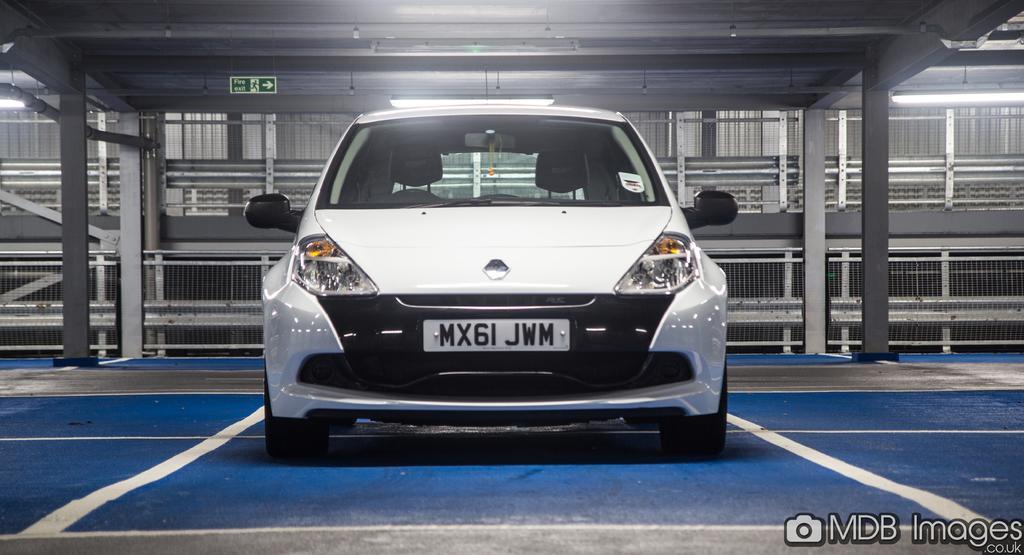Could you give a brief overview of what you see in this image? In the foreground of this image, there is a car on the floor. In the background, we can see the mesh, a shed like structure and the sign board. 